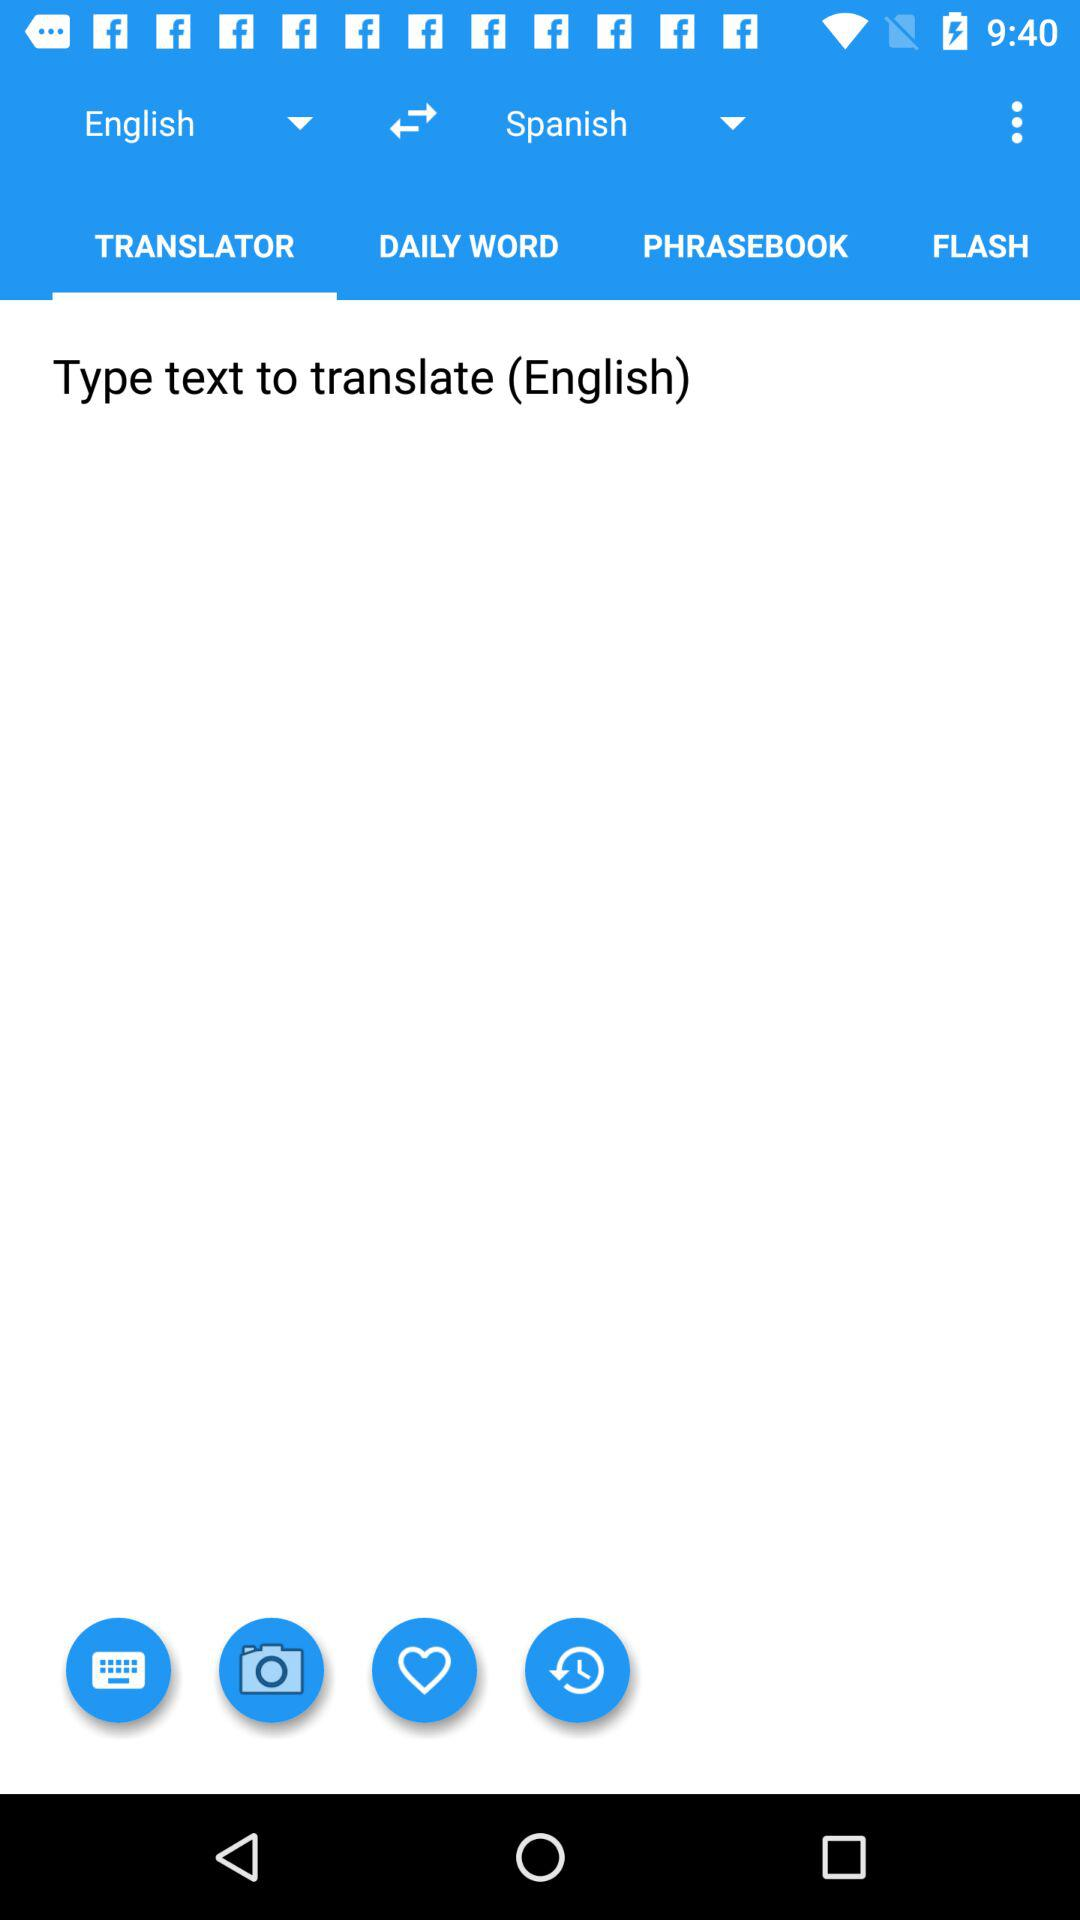Which languages are used for translation? The languages that are used for translation are English and Spanish. 